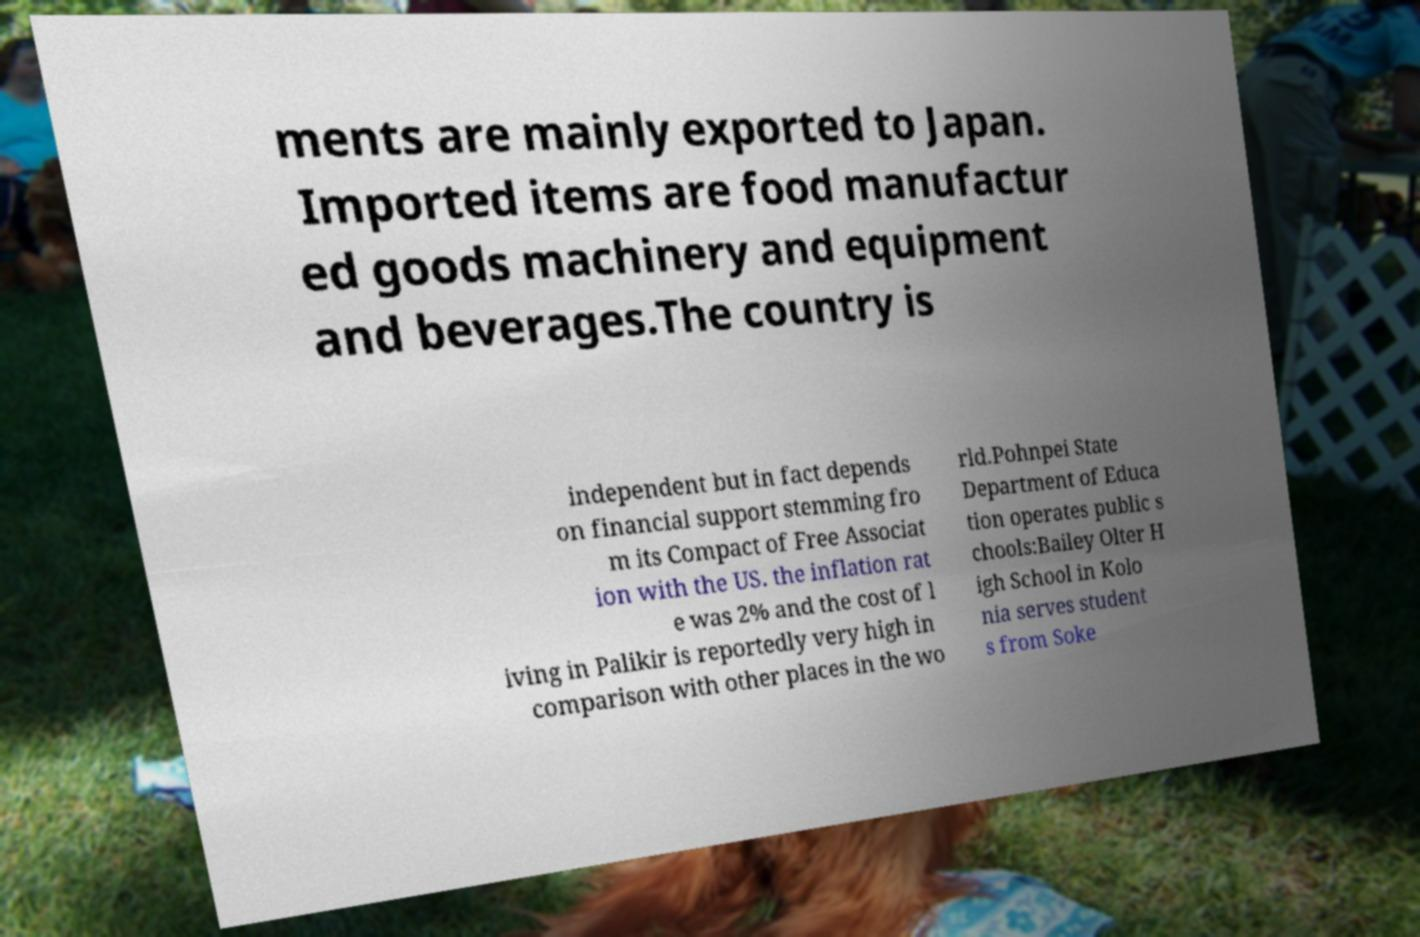Could you assist in decoding the text presented in this image and type it out clearly? ments are mainly exported to Japan. Imported items are food manufactur ed goods machinery and equipment and beverages.The country is independent but in fact depends on financial support stemming fro m its Compact of Free Associat ion with the US. the inflation rat e was 2% and the cost of l iving in Palikir is reportedly very high in comparison with other places in the wo rld.Pohnpei State Department of Educa tion operates public s chools:Bailey Olter H igh School in Kolo nia serves student s from Soke 